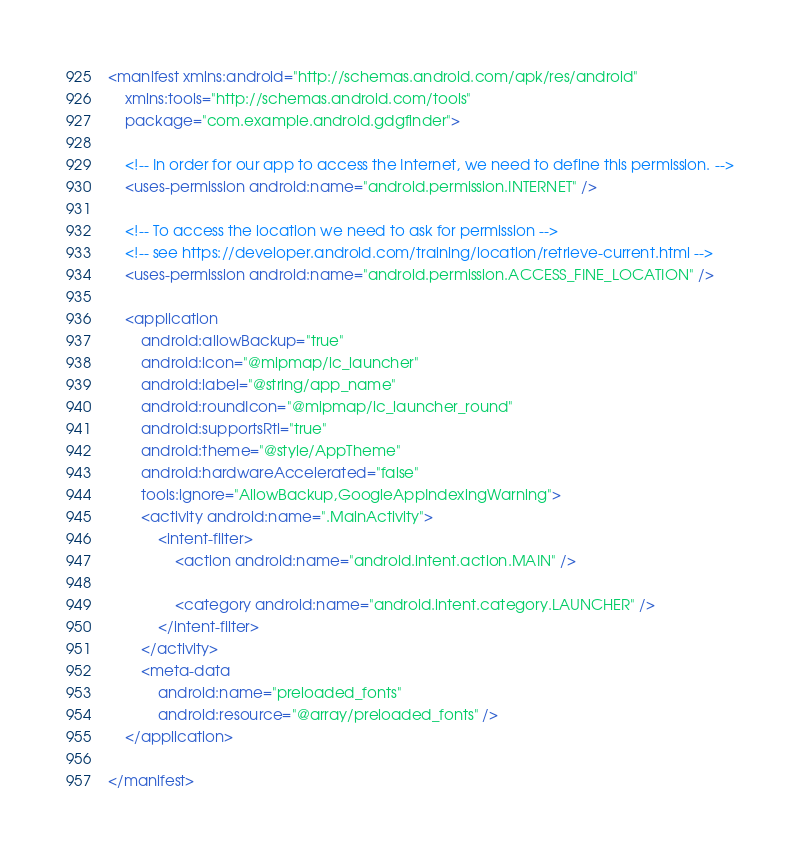<code> <loc_0><loc_0><loc_500><loc_500><_XML_><manifest xmlns:android="http://schemas.android.com/apk/res/android"
    xmlns:tools="http://schemas.android.com/tools"
    package="com.example.android.gdgfinder">

    <!-- In order for our app to access the Internet, we need to define this permission. -->
    <uses-permission android:name="android.permission.INTERNET" />

    <!-- To access the location we need to ask for permission -->
    <!-- see https://developer.android.com/training/location/retrieve-current.html -->
    <uses-permission android:name="android.permission.ACCESS_FINE_LOCATION" />

    <application
        android:allowBackup="true"
        android:icon="@mipmap/ic_launcher"
        android:label="@string/app_name"
        android:roundIcon="@mipmap/ic_launcher_round"
        android:supportsRtl="true"
        android:theme="@style/AppTheme"
        android:hardwareAccelerated="false"
        tools:ignore="AllowBackup,GoogleAppIndexingWarning">
        <activity android:name=".MainActivity">
            <intent-filter>
                <action android:name="android.intent.action.MAIN" />

                <category android:name="android.intent.category.LAUNCHER" />
            </intent-filter>
        </activity>
        <meta-data
            android:name="preloaded_fonts"
            android:resource="@array/preloaded_fonts" />
    </application>

</manifest>
</code> 